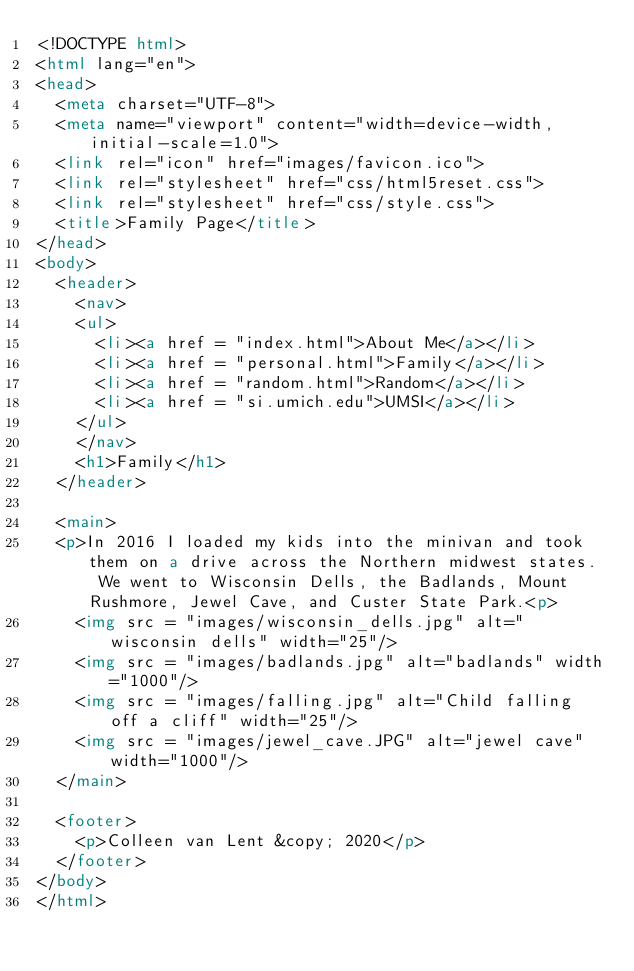Convert code to text. <code><loc_0><loc_0><loc_500><loc_500><_HTML_><!DOCTYPE html>
<html lang="en">
<head>
	<meta charset="UTF-8">
	<meta name="viewport" content="width=device-width, initial-scale=1.0">
	<link rel="icon" href="images/favicon.ico">
	<link rel="stylesheet" href="css/html5reset.css">
	<link rel="stylesheet" href="css/style.css">
	<title>Family Page</title>
</head>
<body>
	<header>
	  <nav>
		<ul>
			<li><a href = "index.html">About Me</a></li>
			<li><a href = "personal.html">Family</a></li>
			<li><a href = "random.html">Random</a></li>
			<li><a href = "si.umich.edu">UMSI</a></li>
		</ul>
	  </nav>
	  <h1>Family</h1>
	</header>

	<main>
	<p>In 2016 I loaded my kids into the minivan and took them on a drive across the Northern midwest states.  We went to Wisconsin Dells, the Badlands, Mount Rushmore, Jewel Cave, and Custer State Park.<p>
		<img src = "images/wisconsin_dells.jpg" alt="wisconsin dells" width="25"/>
		<img src = "images/badlands.jpg" alt="badlands" width="1000"/>
		<img src = "images/falling.jpg" alt="Child falling off a cliff" width="25"/>
		<img src = "images/jewel_cave.JPG" alt="jewel cave" width="1000"/>
	</main>

	<footer>
		<p>Colleen van Lent &copy; 2020</p>
	</footer>
</body>
</html>


</code> 